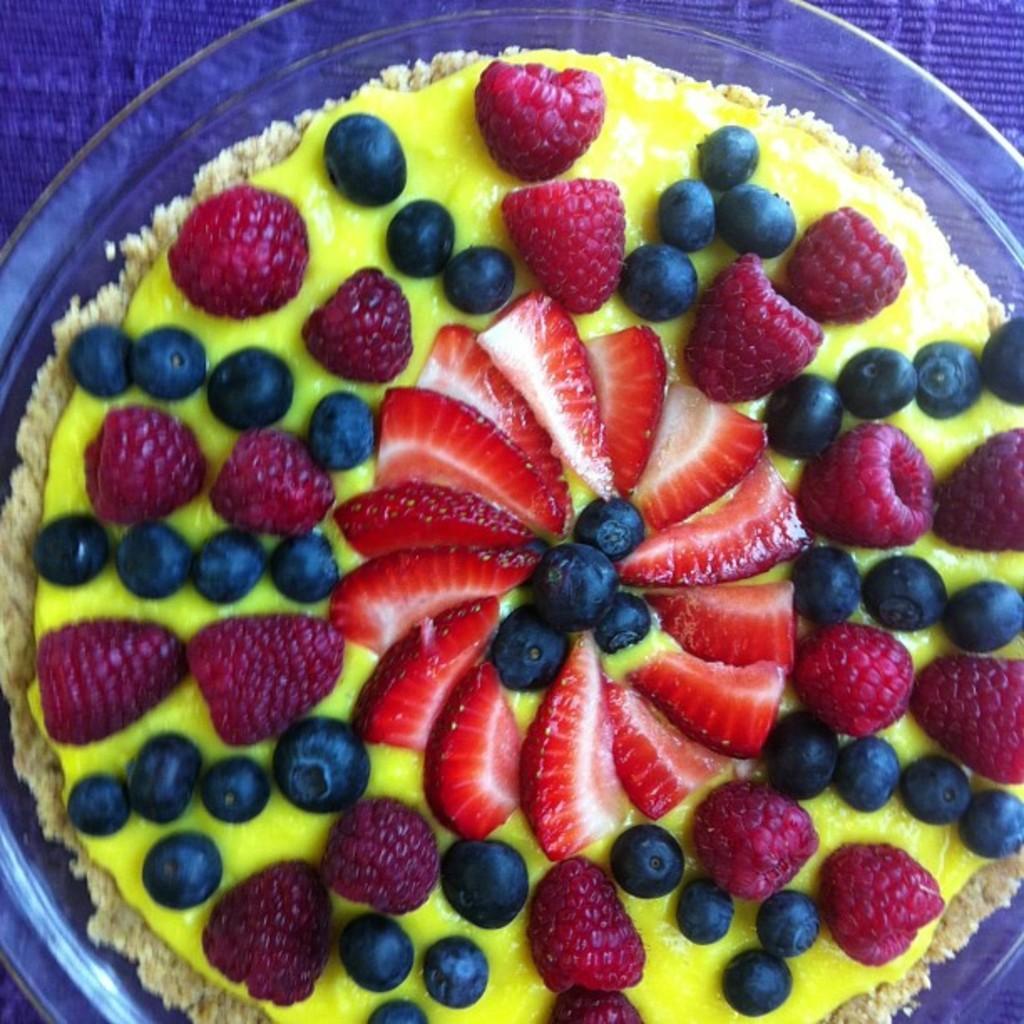Describe this image in one or two sentences. In the image there is a bowl with fruit custard in it, it contains strawberries,grapes and raspberries. 